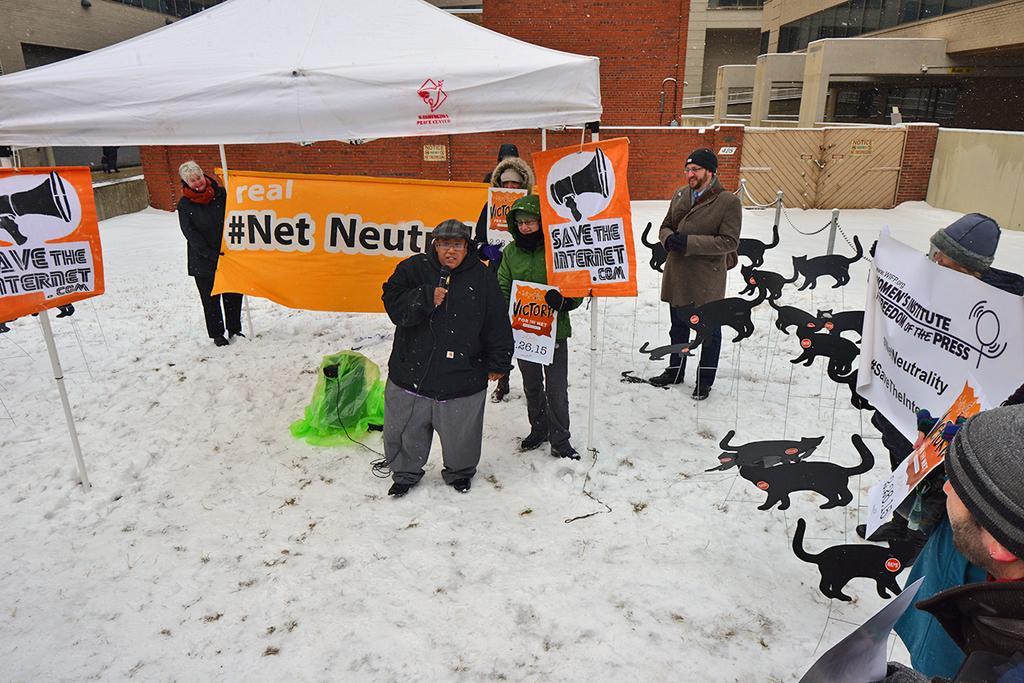Could you give a brief overview of what you see in this image? In this image there are some people who are standing some of them are holding some boards and posters, and one person is holding a mike and talking and in the background there is a tent and buildings. At the bottom there is snow. 